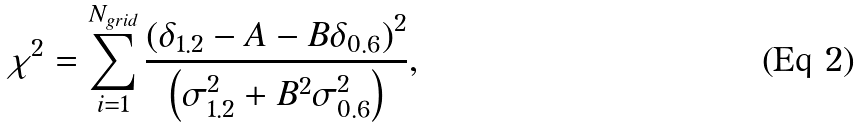<formula> <loc_0><loc_0><loc_500><loc_500>\chi ^ { 2 } = \sum _ { i = 1 } ^ { N _ { g r i d } } \frac { \left ( \delta _ { 1 . 2 } - A - B \delta _ { 0 . 6 } \right ) ^ { 2 } } { \left ( \sigma _ { 1 . 2 } ^ { 2 } + B ^ { 2 } \sigma _ { 0 . 6 } ^ { 2 } \right ) } ,</formula> 